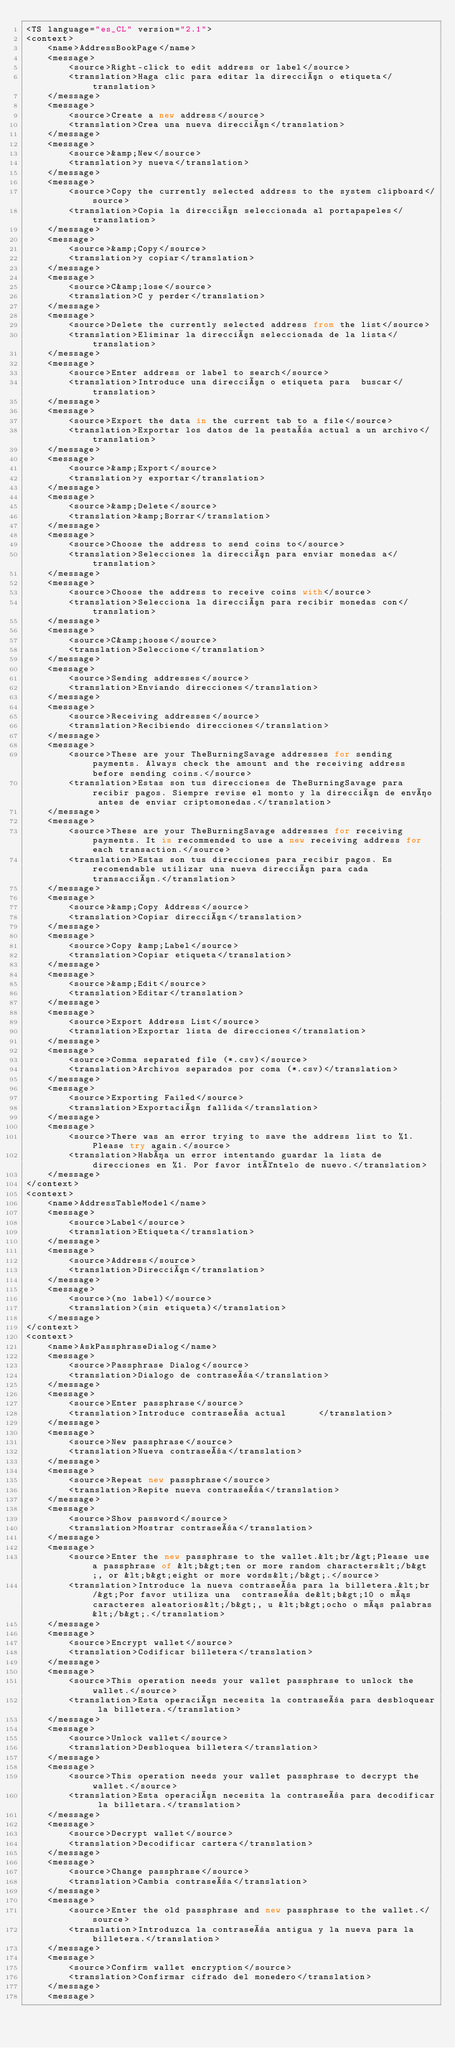Convert code to text. <code><loc_0><loc_0><loc_500><loc_500><_TypeScript_><TS language="es_CL" version="2.1">
<context>
    <name>AddressBookPage</name>
    <message>
        <source>Right-click to edit address or label</source>
        <translation>Haga clic para editar la dirección o etiqueta</translation>
    </message>
    <message>
        <source>Create a new address</source>
        <translation>Crea una nueva dirección</translation>
    </message>
    <message>
        <source>&amp;New</source>
        <translation>y nueva</translation>
    </message>
    <message>
        <source>Copy the currently selected address to the system clipboard</source>
        <translation>Copia la dirección seleccionada al portapapeles</translation>
    </message>
    <message>
        <source>&amp;Copy</source>
        <translation>y copiar</translation>
    </message>
    <message>
        <source>C&amp;lose</source>
        <translation>C y perder</translation>
    </message>
    <message>
        <source>Delete the currently selected address from the list</source>
        <translation>Eliminar la dirección seleccionada de la lista</translation>
    </message>
    <message>
        <source>Enter address or label to search</source>
        <translation>Introduce una dirección o etiqueta para  buscar</translation>
    </message>
    <message>
        <source>Export the data in the current tab to a file</source>
        <translation>Exportar los datos de la pestaña actual a un archivo</translation>
    </message>
    <message>
        <source>&amp;Export</source>
        <translation>y exportar</translation>
    </message>
    <message>
        <source>&amp;Delete</source>
        <translation>&amp;Borrar</translation>
    </message>
    <message>
        <source>Choose the address to send coins to</source>
        <translation>Selecciones la dirección para enviar monedas a</translation>
    </message>
    <message>
        <source>Choose the address to receive coins with</source>
        <translation>Selecciona la dirección para recibir monedas con</translation>
    </message>
    <message>
        <source>C&amp;hoose</source>
        <translation>Seleccione</translation>
    </message>
    <message>
        <source>Sending addresses</source>
        <translation>Enviando direcciones</translation>
    </message>
    <message>
        <source>Receiving addresses</source>
        <translation>Recibiendo direcciones</translation>
    </message>
    <message>
        <source>These are your TheBurningSavage addresses for sending payments. Always check the amount and the receiving address before sending coins.</source>
        <translation>Estas son tus direcciones de TheBurningSavage para recibir pagos. Siempre revise el monto y la dirección de envío antes de enviar criptomonedas.</translation>
    </message>
    <message>
        <source>These are your TheBurningSavage addresses for receiving payments. It is recommended to use a new receiving address for each transaction.</source>
        <translation>Estas son tus direcciones para recibir pagos. Es recomendable utilizar una nueva dirección para cada transacción.</translation>
    </message>
    <message>
        <source>&amp;Copy Address</source>
        <translation>Copiar dirección</translation>
    </message>
    <message>
        <source>Copy &amp;Label</source>
        <translation>Copiar etiqueta</translation>
    </message>
    <message>
        <source>&amp;Edit</source>
        <translation>Editar</translation>
    </message>
    <message>
        <source>Export Address List</source>
        <translation>Exportar lista de direcciones</translation>
    </message>
    <message>
        <source>Comma separated file (*.csv)</source>
        <translation>Archivos separados por coma (*.csv)</translation>
    </message>
    <message>
        <source>Exporting Failed</source>
        <translation>Exportación fallida</translation>
    </message>
    <message>
        <source>There was an error trying to save the address list to %1. Please try again.</source>
        <translation>Había un error intentando guardar la lista de direcciones en %1. Por favor inténtelo de nuevo.</translation>
    </message>
</context>
<context>
    <name>AddressTableModel</name>
    <message>
        <source>Label</source>
        <translation>Etiqueta</translation>
    </message>
    <message>
        <source>Address</source>
        <translation>Dirección</translation>
    </message>
    <message>
        <source>(no label)</source>
        <translation>(sin etiqueta)</translation>
    </message>
</context>
<context>
    <name>AskPassphraseDialog</name>
    <message>
        <source>Passphrase Dialog</source>
        <translation>Dialogo de contraseña</translation>
    </message>
    <message>
        <source>Enter passphrase</source>
        <translation>Introduce contraseña actual      </translation>
    </message>
    <message>
        <source>New passphrase</source>
        <translation>Nueva contraseña</translation>
    </message>
    <message>
        <source>Repeat new passphrase</source>
        <translation>Repite nueva contraseña</translation>
    </message>
    <message>
        <source>Show password</source>
        <translation>Mostrar contraseña</translation>
    </message>
    <message>
        <source>Enter the new passphrase to the wallet.&lt;br/&gt;Please use a passphrase of &lt;b&gt;ten or more random characters&lt;/b&gt;, or &lt;b&gt;eight or more words&lt;/b&gt;.</source>
        <translation>Introduce la nueva contraseña para la billetera.&lt;br/&gt;Por favor utiliza una  contraseña de&lt;b&gt;10 o más caracteres aleatorios&lt;/b&gt;, u &lt;b&gt;ocho o más palabras&lt;/b&gt;.</translation>
    </message>
    <message>
        <source>Encrypt wallet</source>
        <translation>Codificar billetera</translation>
    </message>
    <message>
        <source>This operation needs your wallet passphrase to unlock the wallet.</source>
        <translation>Esta operación necesita la contraseña para desbloquear la billetera.</translation>
    </message>
    <message>
        <source>Unlock wallet</source>
        <translation>Desbloquea billetera</translation>
    </message>
    <message>
        <source>This operation needs your wallet passphrase to decrypt the wallet.</source>
        <translation>Esta operación necesita la contraseña para decodificar la billetara.</translation>
    </message>
    <message>
        <source>Decrypt wallet</source>
        <translation>Decodificar cartera</translation>
    </message>
    <message>
        <source>Change passphrase</source>
        <translation>Cambia contraseña</translation>
    </message>
    <message>
        <source>Enter the old passphrase and new passphrase to the wallet.</source>
        <translation>Introduzca la contraseña antigua y la nueva para la billetera.</translation>
    </message>
    <message>
        <source>Confirm wallet encryption</source>
        <translation>Confirmar cifrado del monedero</translation>
    </message>
    <message></code> 